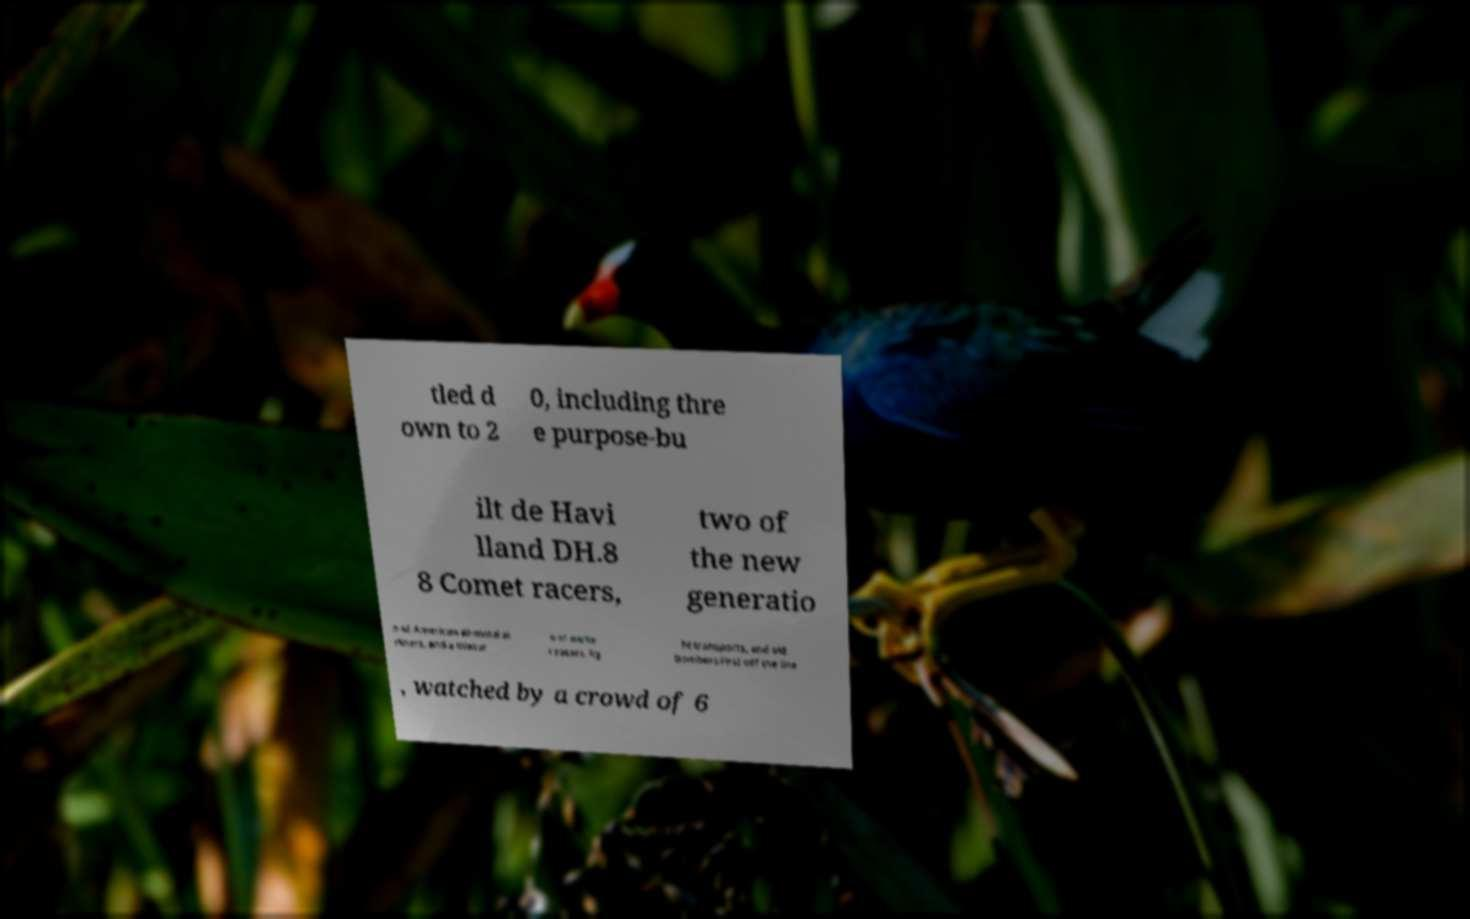Could you assist in decoding the text presented in this image and type it out clearly? tled d own to 2 0, including thre e purpose-bu ilt de Havi lland DH.8 8 Comet racers, two of the new generatio n of American all-metal ai rliners, and a mixtur e of earlie r racers, lig ht transports, and old bombers.First off the line , watched by a crowd of 6 